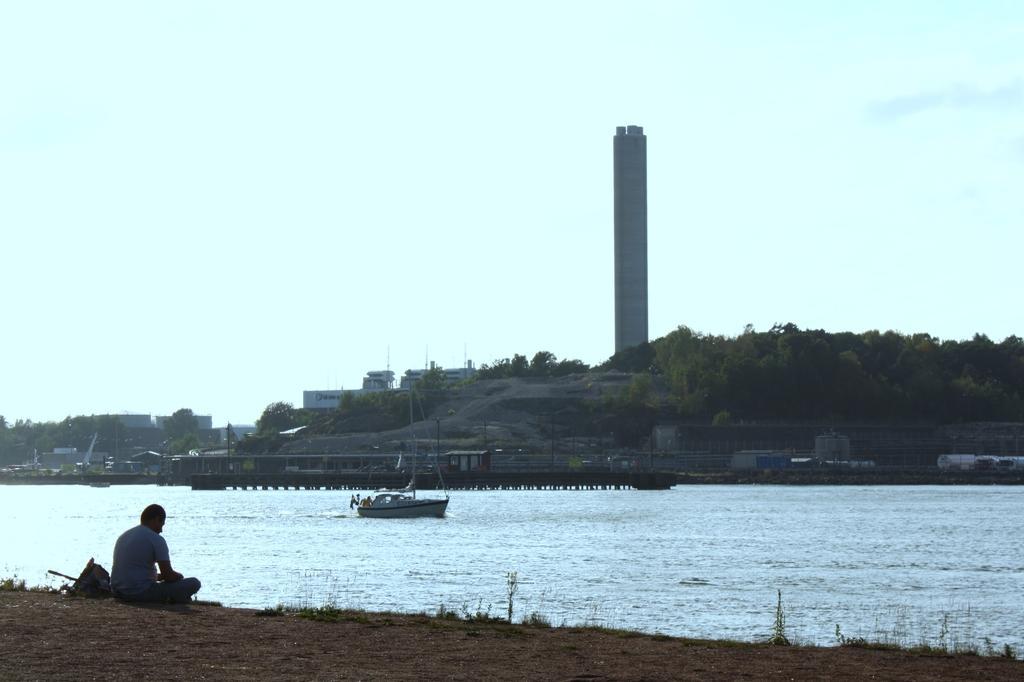In one or two sentences, can you explain what this image depicts? On the left side of the image we can see a man sitting on the ground, before him there is a river and we can see a boat in the river. In the background there is a mesh, trees, tower, buildings, rock and sky. 